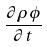<formula> <loc_0><loc_0><loc_500><loc_500>\frac { \partial \rho \phi } { \partial t }</formula> 